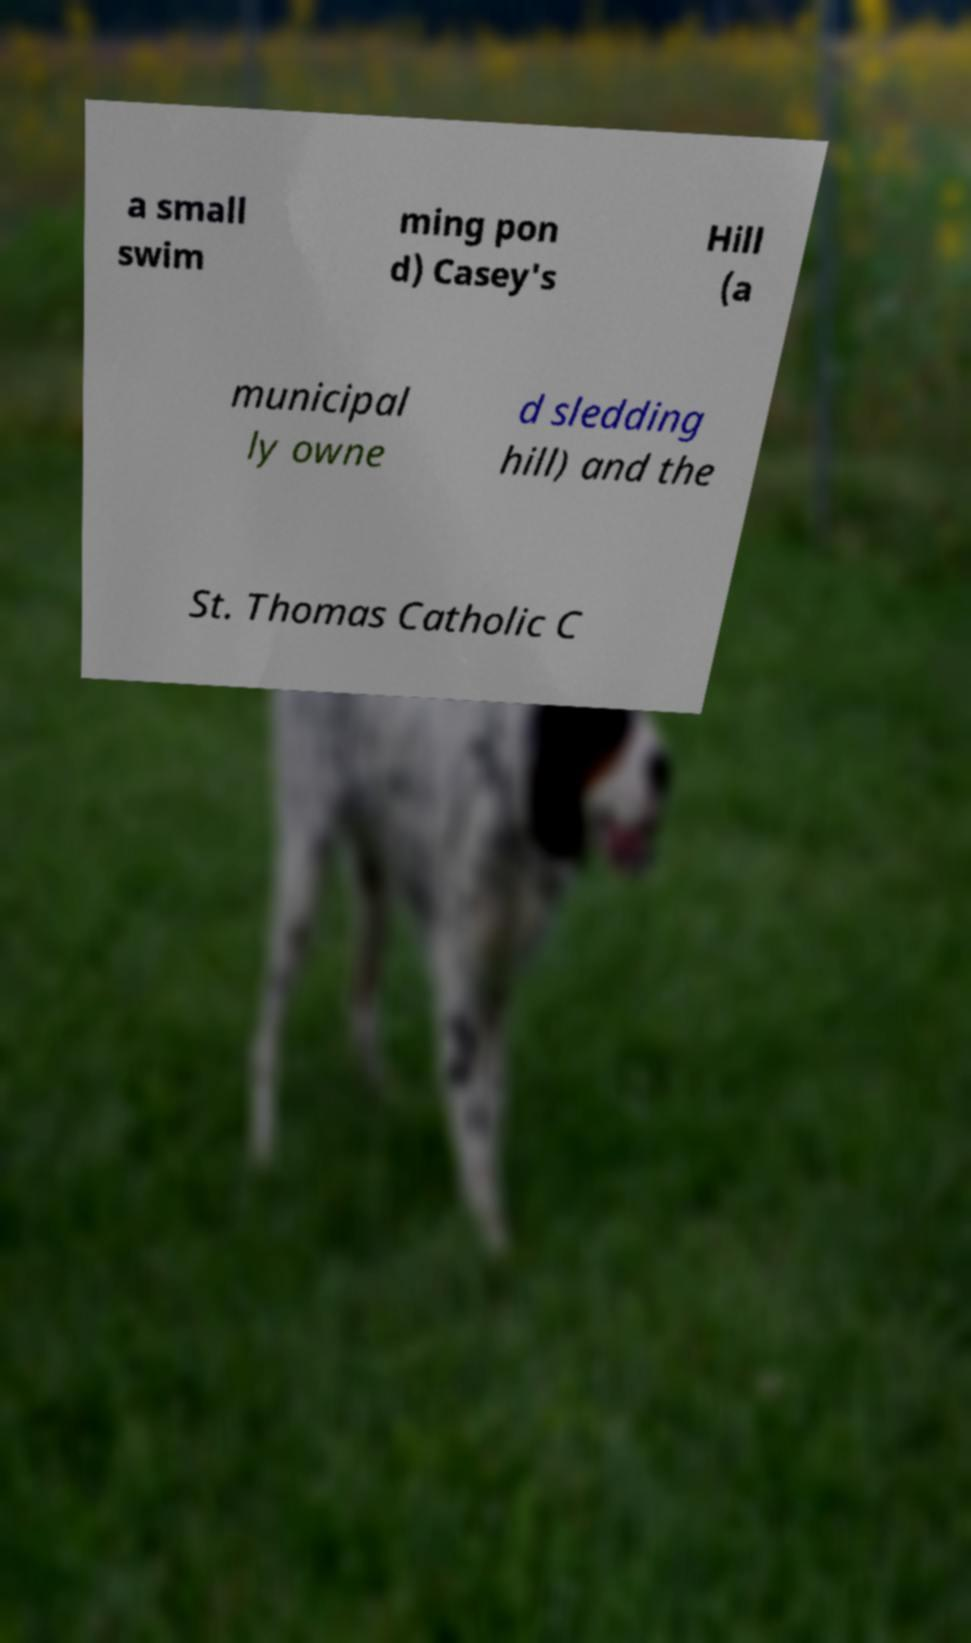What messages or text are displayed in this image? I need them in a readable, typed format. a small swim ming pon d) Casey's Hill (a municipal ly owne d sledding hill) and the St. Thomas Catholic C 